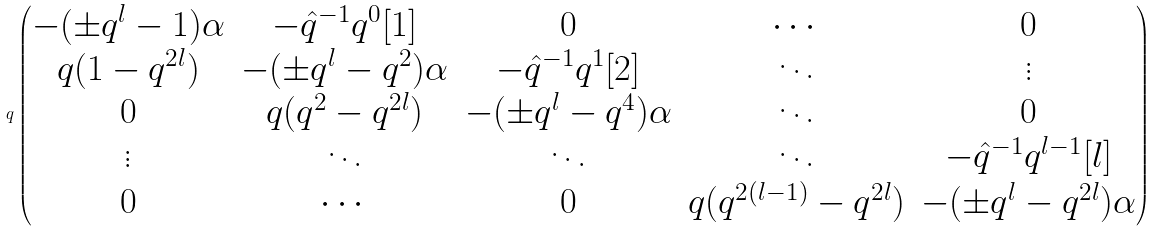<formula> <loc_0><loc_0><loc_500><loc_500>q \begin{pmatrix} - ( \pm q ^ { l } - 1 ) \alpha & - \hat { q } ^ { - 1 } q ^ { 0 } [ 1 ] & 0 & \cdots & 0 \\ q ( 1 - q ^ { 2 l } ) & - ( \pm q ^ { l } - q ^ { 2 } ) \alpha & - \hat { q } ^ { - 1 } q ^ { 1 } [ 2 ] & \ddots & \vdots \\ 0 & q ( q ^ { 2 } - q ^ { 2 l } ) & - ( \pm q ^ { l } - q ^ { 4 } ) \alpha & \ddots & 0 \\ \vdots & \ddots & \ddots & \ddots & - \hat { q } ^ { - 1 } q ^ { l - 1 } [ l ] \\ 0 & \cdots & 0 & q ( q ^ { 2 ( l - 1 ) } - q ^ { 2 l } ) & - ( \pm q ^ { l } - q ^ { 2 l } ) \alpha \end{pmatrix}</formula> 